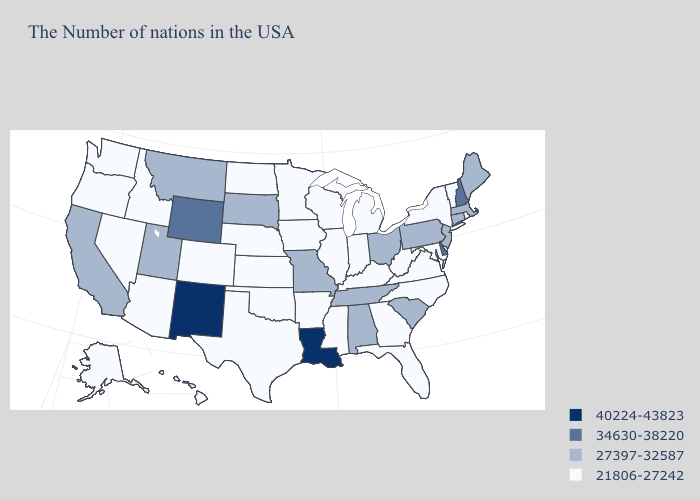What is the value of Arizona?
Give a very brief answer. 21806-27242. Which states hav the highest value in the West?
Answer briefly. New Mexico. Does Louisiana have the highest value in the South?
Quick response, please. Yes. What is the highest value in the Northeast ?
Be succinct. 34630-38220. What is the value of Iowa?
Answer briefly. 21806-27242. Does the map have missing data?
Quick response, please. No. Name the states that have a value in the range 34630-38220?
Quick response, please. New Hampshire, Delaware, Wyoming. How many symbols are there in the legend?
Quick response, please. 4. Does Tennessee have a lower value than New Mexico?
Keep it brief. Yes. What is the value of New York?
Give a very brief answer. 21806-27242. What is the value of Wyoming?
Quick response, please. 34630-38220. Which states have the lowest value in the Northeast?
Quick response, please. Rhode Island, Vermont, New York. Name the states that have a value in the range 34630-38220?
Concise answer only. New Hampshire, Delaware, Wyoming. Name the states that have a value in the range 34630-38220?
Write a very short answer. New Hampshire, Delaware, Wyoming. What is the value of New Hampshire?
Short answer required. 34630-38220. 